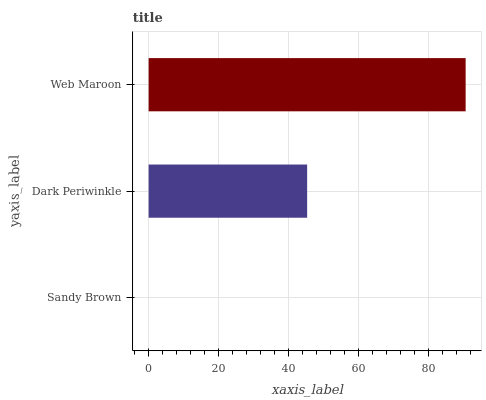Is Sandy Brown the minimum?
Answer yes or no. Yes. Is Web Maroon the maximum?
Answer yes or no. Yes. Is Dark Periwinkle the minimum?
Answer yes or no. No. Is Dark Periwinkle the maximum?
Answer yes or no. No. Is Dark Periwinkle greater than Sandy Brown?
Answer yes or no. Yes. Is Sandy Brown less than Dark Periwinkle?
Answer yes or no. Yes. Is Sandy Brown greater than Dark Periwinkle?
Answer yes or no. No. Is Dark Periwinkle less than Sandy Brown?
Answer yes or no. No. Is Dark Periwinkle the high median?
Answer yes or no. Yes. Is Dark Periwinkle the low median?
Answer yes or no. Yes. Is Web Maroon the high median?
Answer yes or no. No. Is Web Maroon the low median?
Answer yes or no. No. 